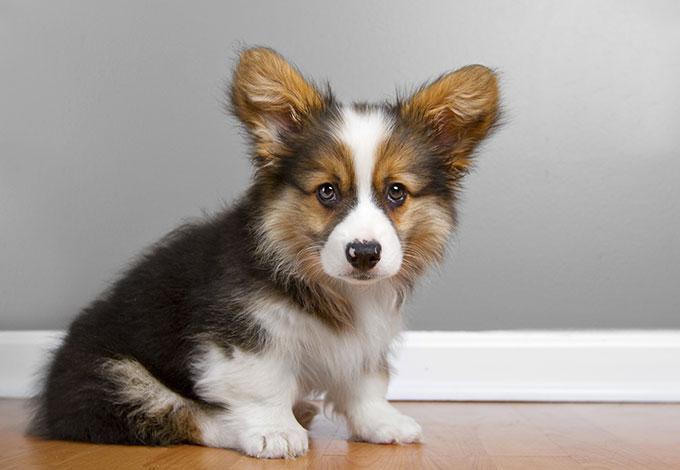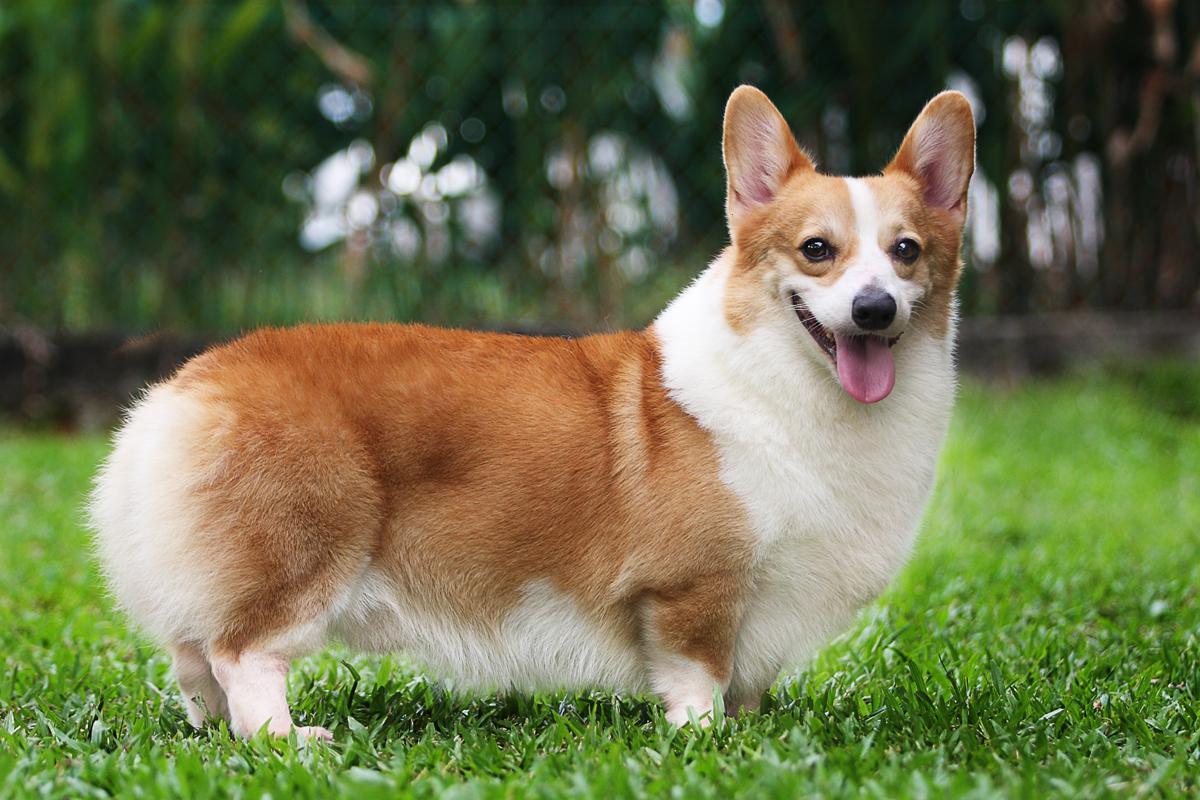The first image is the image on the left, the second image is the image on the right. Assess this claim about the two images: "The dog in the image on the left is sitting.". Correct or not? Answer yes or no. Yes. 